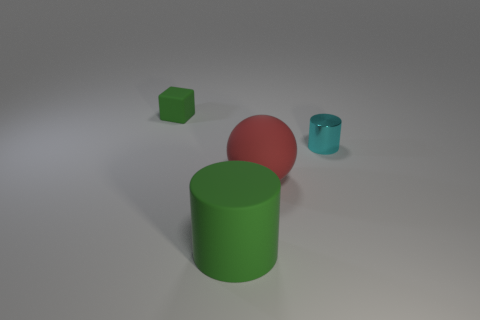Add 4 small cylinders. How many objects exist? 8 Subtract all blocks. How many objects are left? 3 Add 4 cyan objects. How many cyan objects are left? 5 Add 1 large cyan cylinders. How many large cyan cylinders exist? 1 Subtract 0 gray cubes. How many objects are left? 4 Subtract all cylinders. Subtract all tiny cyan objects. How many objects are left? 1 